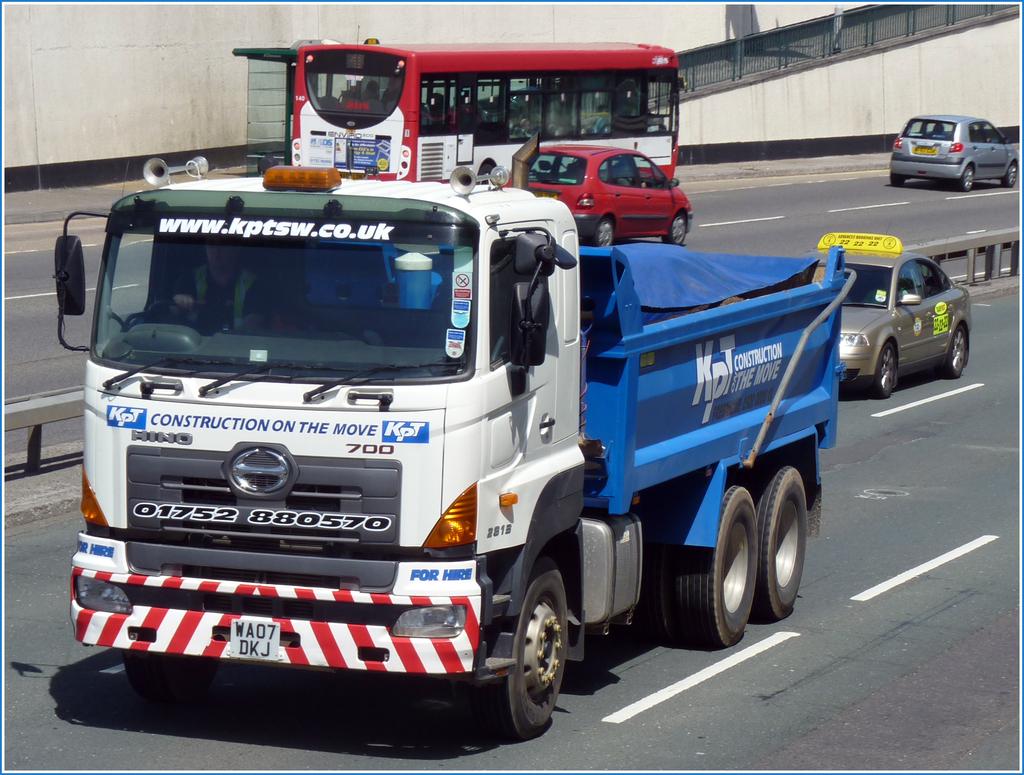What website is on the truck?
Your answer should be compact. Www.kptsw.co.uk. What do they do?
Offer a very short reply. Construction. 